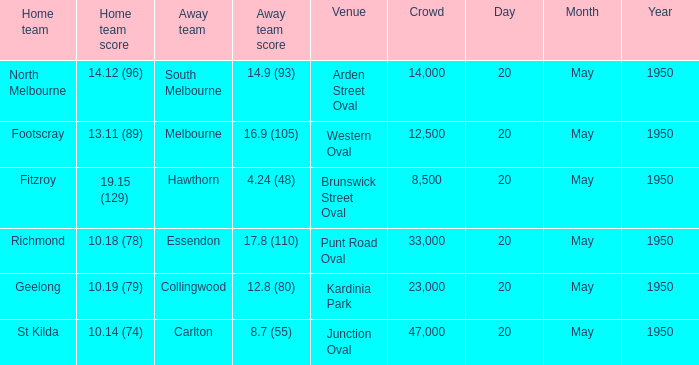8 (110)? 33000.0. 